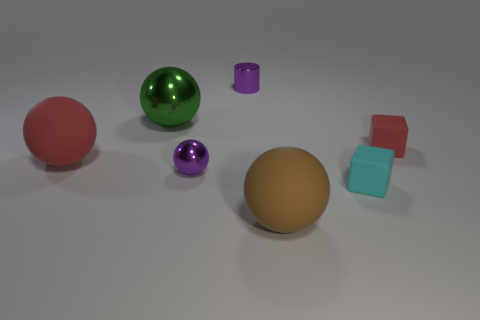Subtract all yellow balls. Subtract all yellow cubes. How many balls are left? 4 Add 1 cyan objects. How many objects exist? 8 Subtract all spheres. How many objects are left? 3 Add 6 big gray matte cylinders. How many big gray matte cylinders exist? 6 Subtract 0 brown blocks. How many objects are left? 7 Subtract all red cylinders. Subtract all small purple metallic cylinders. How many objects are left? 6 Add 2 big green objects. How many big green objects are left? 3 